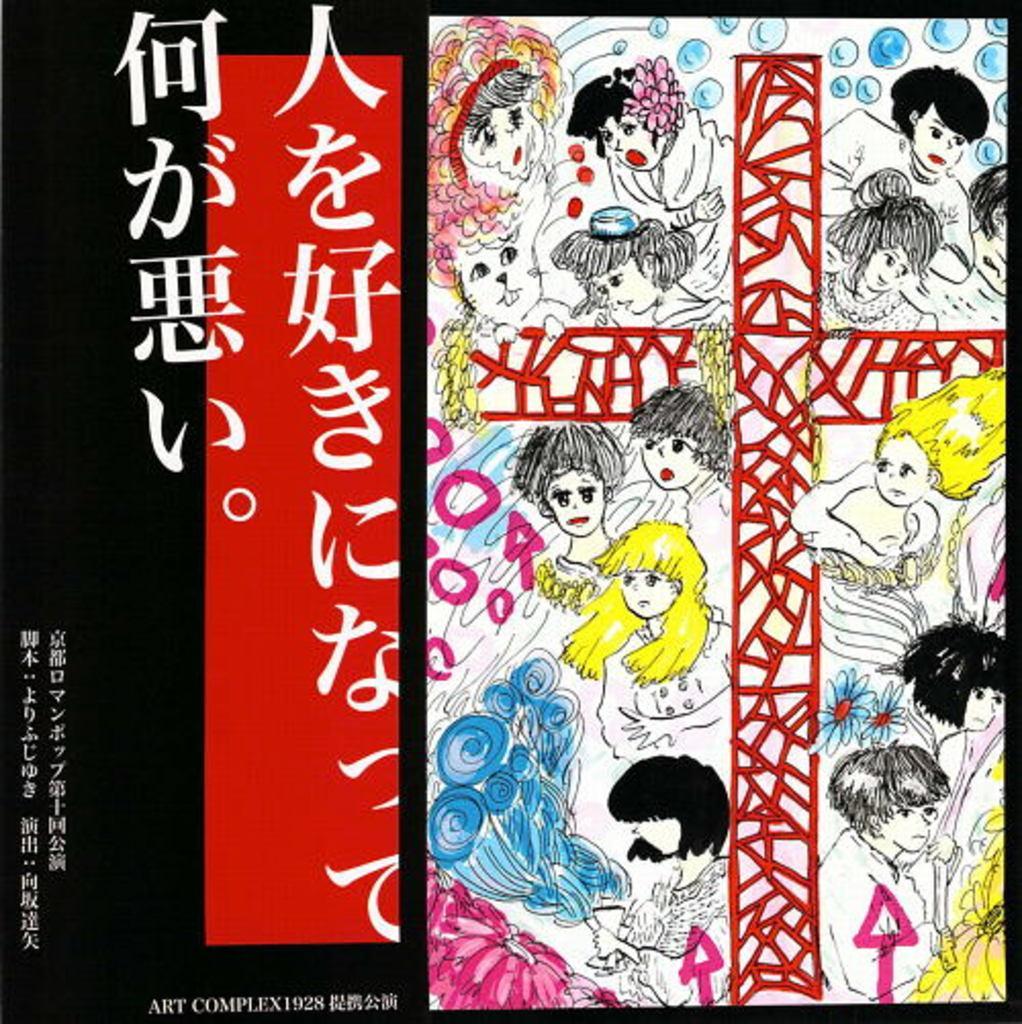How would you summarize this image in a sentence or two? I see there are animated pictures over here and I see few words written over here and I see a watermark over here and it is black and red over here. 